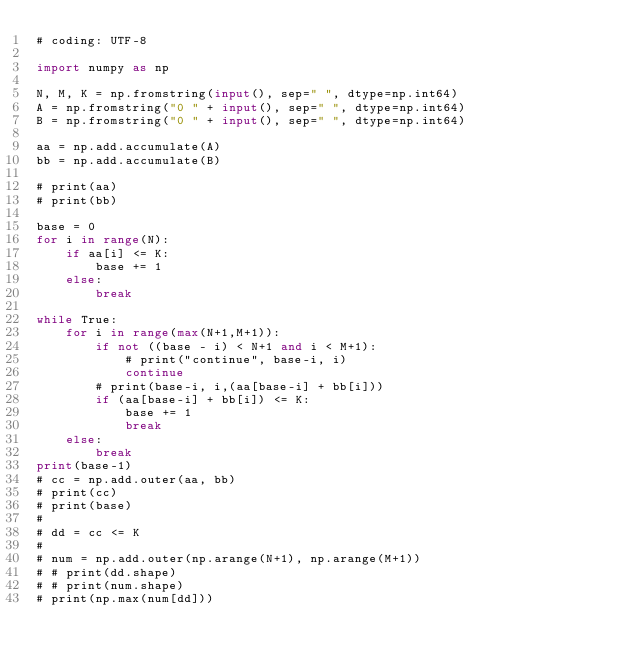Convert code to text. <code><loc_0><loc_0><loc_500><loc_500><_Python_># coding: UTF-8

import numpy as np

N, M, K = np.fromstring(input(), sep=" ", dtype=np.int64)
A = np.fromstring("0 " + input(), sep=" ", dtype=np.int64)
B = np.fromstring("0 " + input(), sep=" ", dtype=np.int64)

aa = np.add.accumulate(A)
bb = np.add.accumulate(B)

# print(aa)
# print(bb)

base = 0
for i in range(N):
    if aa[i] <= K:
        base += 1
    else:
        break

while True:
    for i in range(max(N+1,M+1)):
        if not ((base - i) < N+1 and i < M+1):
            # print("continue", base-i, i)
            continue
        # print(base-i, i,(aa[base-i] + bb[i]))
        if (aa[base-i] + bb[i]) <= K:
            base += 1
            break
    else:
        break
print(base-1)
# cc = np.add.outer(aa, bb)
# print(cc)
# print(base)
#
# dd = cc <= K
#
# num = np.add.outer(np.arange(N+1), np.arange(M+1))
# # print(dd.shape)
# # print(num.shape)
# print(np.max(num[dd]))</code> 